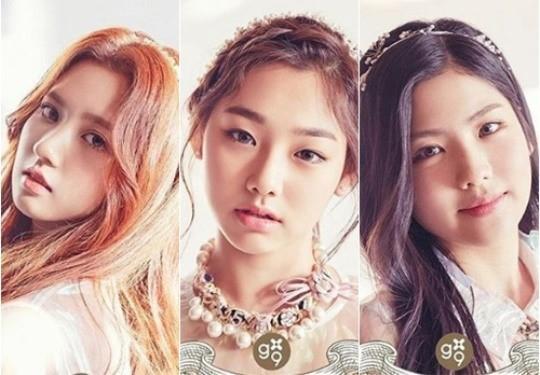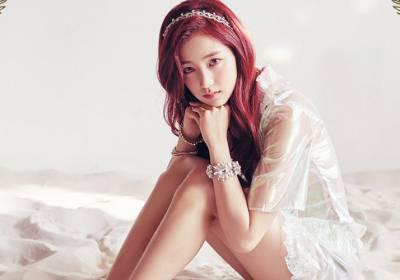The first image is the image on the left, the second image is the image on the right. Given the left and right images, does the statement "There are more than four women in total." hold true? Answer yes or no. No. 